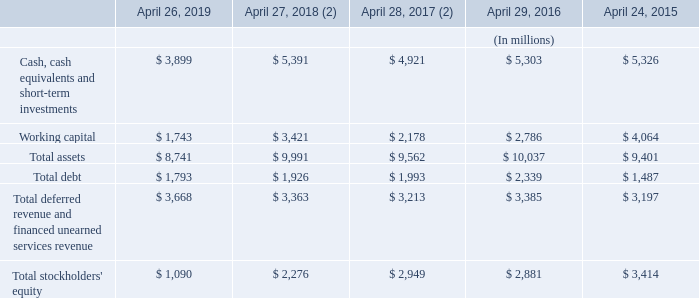Item 6. Selected Financial Data
The following selected consolidated financial data set forth below was derived from our historical audited consolidated financial statements and should be read in conjunction with Item 7 – Management’s Discussion and Analysis of Financial Condition and Results of Operations and Item 8 – Financial Statements and Supplementary Data, and other financial data included elsewhere in this Annual Report on Form 10-K. Our historical results of operations are not indicative of our future results of operations.
(2) Fiscal 2018 and 2017 have been adjusted for our retrospective adoption of the new accounting standard Revenue from Contracts with Customers (ASC 606). Refer to Note 7 – Revenue of the Notes to Consolidated Financial Statements for details.
What was the working capital in 2019?
Answer scale should be: million. 1,743. What years does the table provide information for total assets? 2019, 2018, 2017, 2016, 2015. What was the total debt in 2015?
Answer scale should be: million. 1,487. What was the change in working capital between 2015 and 2016?
Answer scale should be: million. 2,786-4,064
Answer: -1278. How many years did total assets exceed $10,000 million? 2016
Answer: 1. What was the percentage change in Total stockholders' equity between 2018 and 2019?
Answer scale should be: percent. (1,090-2,276)/2,276
Answer: -52.11. 